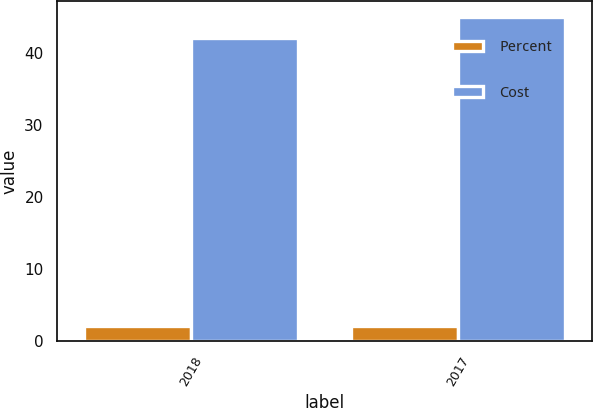Convert chart to OTSL. <chart><loc_0><loc_0><loc_500><loc_500><stacked_bar_chart><ecel><fcel>2018<fcel>2017<nl><fcel>Percent<fcel>2.13<fcel>2.08<nl><fcel>Cost<fcel>42<fcel>45<nl></chart> 